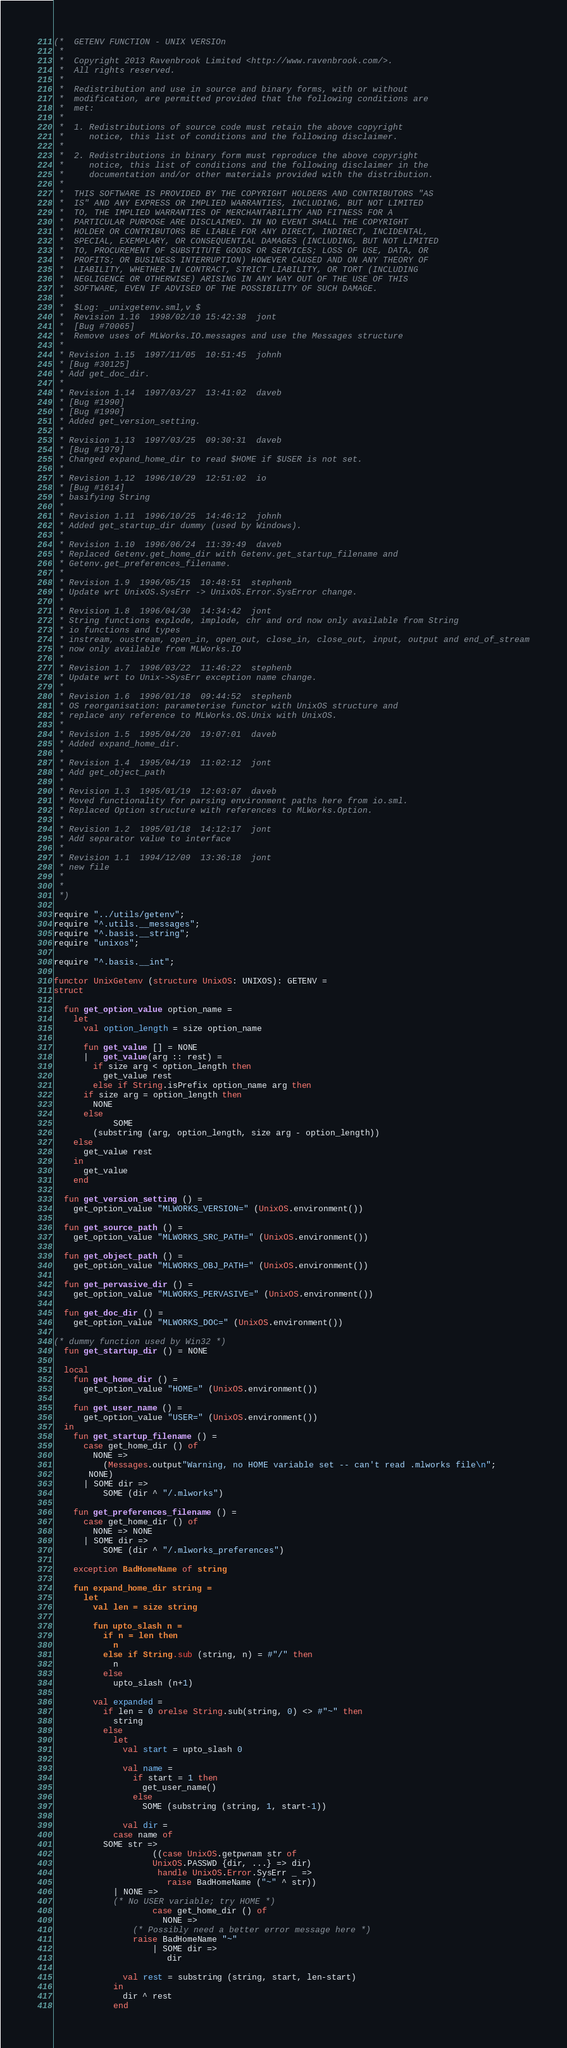Convert code to text. <code><loc_0><loc_0><loc_500><loc_500><_SML_>(*  GETENV FUNCTION - UNIX VERSIOn
 *
 *  Copyright 2013 Ravenbrook Limited <http://www.ravenbrook.com/>.
 *  All rights reserved.
 *  
 *  Redistribution and use in source and binary forms, with or without
 *  modification, are permitted provided that the following conditions are
 *  met:
 *  
 *  1. Redistributions of source code must retain the above copyright
 *     notice, this list of conditions and the following disclaimer.
 *  
 *  2. Redistributions in binary form must reproduce the above copyright
 *     notice, this list of conditions and the following disclaimer in the
 *     documentation and/or other materials provided with the distribution.
 *  
 *  THIS SOFTWARE IS PROVIDED BY THE COPYRIGHT HOLDERS AND CONTRIBUTORS "AS
 *  IS" AND ANY EXPRESS OR IMPLIED WARRANTIES, INCLUDING, BUT NOT LIMITED
 *  TO, THE IMPLIED WARRANTIES OF MERCHANTABILITY AND FITNESS FOR A
 *  PARTICULAR PURPOSE ARE DISCLAIMED. IN NO EVENT SHALL THE COPYRIGHT
 *  HOLDER OR CONTRIBUTORS BE LIABLE FOR ANY DIRECT, INDIRECT, INCIDENTAL,
 *  SPECIAL, EXEMPLARY, OR CONSEQUENTIAL DAMAGES (INCLUDING, BUT NOT LIMITED
 *  TO, PROCUREMENT OF SUBSTITUTE GOODS OR SERVICES; LOSS OF USE, DATA, OR
 *  PROFITS; OR BUSINESS INTERRUPTION) HOWEVER CAUSED AND ON ANY THEORY OF
 *  LIABILITY, WHETHER IN CONTRACT, STRICT LIABILITY, OR TORT (INCLUDING
 *  NEGLIGENCE OR OTHERWISE) ARISING IN ANY WAY OUT OF THE USE OF THIS
 *  SOFTWARE, EVEN IF ADVISED OF THE POSSIBILITY OF SUCH DAMAGE.
 *
 *  $Log: _unixgetenv.sml,v $
 *  Revision 1.16  1998/02/10 15:42:38  jont
 *  [Bug #70065]
 *  Remove uses of MLWorks.IO.messages and use the Messages structure
 *
 * Revision 1.15  1997/11/05  10:51:45  johnh
 * [Bug #30125]
 * Add get_doc_dir.
 *
 * Revision 1.14  1997/03/27  13:41:02  daveb
 * [Bug #1990]
 * [Bug #1990]
 * Added get_version_setting.
 *
 * Revision 1.13  1997/03/25  09:30:31  daveb
 * [Bug #1979]
 * Changed expand_home_dir to read $HOME if $USER is not set.
 *
 * Revision 1.12  1996/10/29  12:51:02  io
 * [Bug #1614]
 * basifying String
 *
 * Revision 1.11  1996/10/25  14:46:12  johnh
 * Added get_startup_dir dummy (used by Windows).
 *
 * Revision 1.10  1996/06/24  11:39:49  daveb
 * Replaced Getenv.get_home_dir with Getenv.get_startup_filename and
 * Getenv.get_preferences_filename.
 *
 * Revision 1.9  1996/05/15  10:48:51  stephenb
 * Update wrt UnixOS.SysErr -> UnixOS.Error.SysError change.
 *
 * Revision 1.8  1996/04/30  14:34:42  jont
 * String functions explode, implode, chr and ord now only available from String
 * io functions and types
 * instream, oustream, open_in, open_out, close_in, close_out, input, output and end_of_stream
 * now only available from MLWorks.IO
 *
 * Revision 1.7  1996/03/22  11:46:22  stephenb
 * Update wrt to Unix->SysErr exception name change.
 *
 * Revision 1.6  1996/01/18  09:44:52  stephenb
 * OS reorganisation: parameterise functor with UnixOS structure and
 * replace any reference to MLWorks.OS.Unix with UnixOS.
 *
 * Revision 1.5  1995/04/20  19:07:01  daveb
 * Added expand_home_dir.
 *
 * Revision 1.4  1995/04/19  11:02:12  jont
 * Add get_object_path
 *
 * Revision 1.3  1995/01/19  12:03:07  daveb
 * Moved functionality for parsing environment paths here from io.sml.
 * Replaced Option structure with references to MLWorks.Option.
 *
 * Revision 1.2  1995/01/18  14:12:17  jont
 * Add separator value to interface
 *
 * Revision 1.1  1994/12/09  13:36:18  jont
 * new file
 *
 *
 *)

require "../utils/getenv";
require "^.utils.__messages";
require "^.basis.__string";
require "unixos";

require "^.basis.__int";

functor UnixGetenv (structure UnixOS: UNIXOS): GETENV =
struct

  fun get_option_value option_name =
    let
      val option_length = size option_name

      fun get_value [] = NONE
      |   get_value(arg :: rest) =
        if size arg < option_length then
          get_value rest
        else if String.isPrefix option_name arg then
	  if size arg = option_length then
	    NONE
	  else
            SOME
	    (substring (arg, option_length, size arg - option_length))
	else
	  get_value rest
    in
      get_value
    end

  fun get_version_setting () =
    get_option_value "MLWORKS_VERSION=" (UnixOS.environment())

  fun get_source_path () =
    get_option_value "MLWORKS_SRC_PATH=" (UnixOS.environment())

  fun get_object_path () =
    get_option_value "MLWORKS_OBJ_PATH=" (UnixOS.environment())

  fun get_pervasive_dir () =
    get_option_value "MLWORKS_PERVASIVE=" (UnixOS.environment())

  fun get_doc_dir () = 
    get_option_value "MLWORKS_DOC=" (UnixOS.environment())

(* dummy function used by Win32 *)
  fun get_startup_dir () = NONE

  local
    fun get_home_dir () =
      get_option_value "HOME=" (UnixOS.environment())

    fun get_user_name () = 
      get_option_value "USER=" (UnixOS.environment())
  in
    fun get_startup_filename () =
      case get_home_dir () of
        NONE =>
          (Messages.output"Warning, no HOME variable set -- can't read .mlworks file\n";
	   NONE)
      | SOME dir =>
          SOME (dir ^ "/.mlworks")
  
    fun get_preferences_filename () =
      case get_home_dir () of
        NONE => NONE
      | SOME dir =>
          SOME (dir ^ "/.mlworks_preferences")

    exception BadHomeName of string

    fun expand_home_dir string =
      let
        val len = size string

        fun upto_slash n =
          if n = len then
            n
          else if String.sub (string, n) = #"/" then
            n
          else
            upto_slash (n+1)

        val expanded =
          if len = 0 orelse String.sub(string, 0) <> #"~" then
            string
          else
            let
              val start = upto_slash 0
  
              val name =
                if start = 1 then
                  get_user_name()
                else
                  SOME (substring (string, 1, start-1))
  
              val dir =
	        case name of
		  SOME str =>
                    ((case UnixOS.getpwnam str of
	                UnixOS.PASSWD {dir, ...} => dir)
                     handle UnixOS.Error.SysErr _ =>
                       raise BadHomeName ("~" ^ str))
	        | NONE =>
		    (* No USER variable; try HOME *)
                    case get_home_dir () of
                      NONE =>
		        (* Possibly need a better error message here *)
		        raise BadHomeName "~"
                    | SOME dir =>
                       dir 

              val rest = substring (string, start, len-start)
            in
              dir ^ rest
            end</code> 